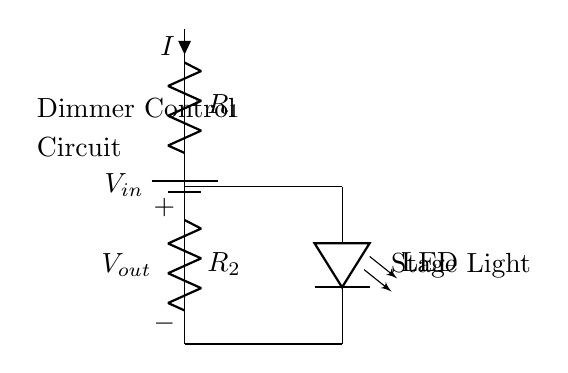What component controls the brightness of the LED? The brightness of the LED is controlled by the resistor R2 in the voltage divider, which adjusts the output voltage (Vout) and subsequently influences the LED brightness.
Answer: R2 What is the function of R1 in this circuit? R1 is part of the voltage divider that helps to drop the input voltage (Vin) down to a lower voltage (Vout) suitable for the LED to operate properly.
Answer: Voltage drop What is the output voltage (Vout) dependent on? The output voltage (Vout) is dependent on the ratio of the resistances R1 and R2 in the voltage divider, which determines how the input voltage is split between them.
Answer: R1 and R2 ratio What does the LED indicate in this circuit? The LED indicates that the circuit is working and also visually represents the dimming effect controlled by the voltage divider.
Answer: Operational status How does a change in R2 affect the LED? A decrease in R2 will increase the output voltage (Vout), causing the LED to become brighter, while an increase in R2 will decrease Vout and dim the LED.
Answer: Adjusts brightness What type of circuit is represented here? The circuit represented here is a voltage divider circuit specifically designed for dimming LED stage lighting, where the output voltage is controlled by resistor values.
Answer: Voltage divider circuit What is the main purpose of this circuit? The main purpose of this circuit is to control the brightness of the LED stage lighting by adjusting the voltage that is applied to the LED.
Answer: Dimming control 